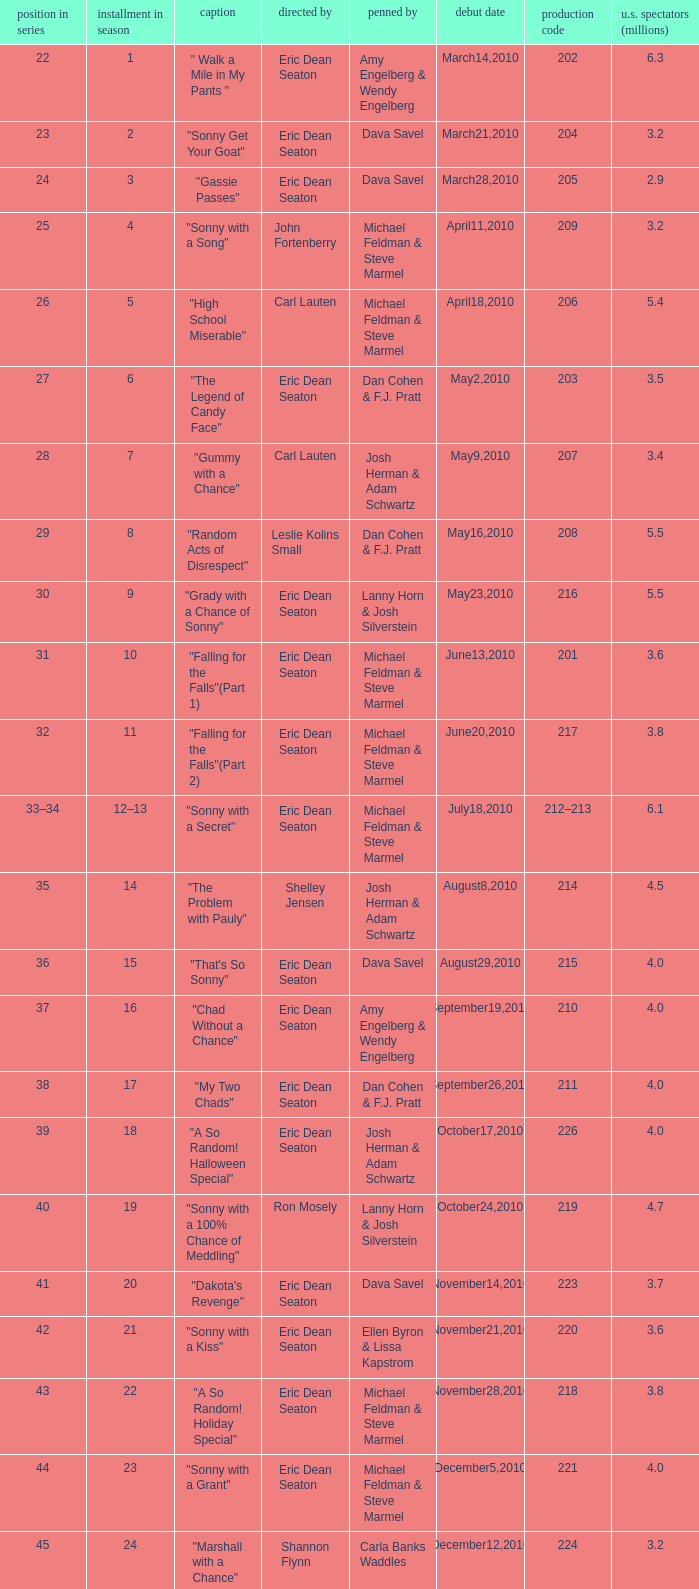Would you be able to parse every entry in this table? {'header': ['position in series', 'installment in season', 'caption', 'directed by', 'penned by', 'debut date', 'production code', 'u.s. spectators (millions)'], 'rows': [['22', '1', '" Walk a Mile in My Pants "', 'Eric Dean Seaton', 'Amy Engelberg & Wendy Engelberg', 'March14,2010', '202', '6.3'], ['23', '2', '"Sonny Get Your Goat"', 'Eric Dean Seaton', 'Dava Savel', 'March21,2010', '204', '3.2'], ['24', '3', '"Gassie Passes"', 'Eric Dean Seaton', 'Dava Savel', 'March28,2010', '205', '2.9'], ['25', '4', '"Sonny with a Song"', 'John Fortenberry', 'Michael Feldman & Steve Marmel', 'April11,2010', '209', '3.2'], ['26', '5', '"High School Miserable"', 'Carl Lauten', 'Michael Feldman & Steve Marmel', 'April18,2010', '206', '5.4'], ['27', '6', '"The Legend of Candy Face"', 'Eric Dean Seaton', 'Dan Cohen & F.J. Pratt', 'May2,2010', '203', '3.5'], ['28', '7', '"Gummy with a Chance"', 'Carl Lauten', 'Josh Herman & Adam Schwartz', 'May9,2010', '207', '3.4'], ['29', '8', '"Random Acts of Disrespect"', 'Leslie Kolins Small', 'Dan Cohen & F.J. Pratt', 'May16,2010', '208', '5.5'], ['30', '9', '"Grady with a Chance of Sonny"', 'Eric Dean Seaton', 'Lanny Horn & Josh Silverstein', 'May23,2010', '216', '5.5'], ['31', '10', '"Falling for the Falls"(Part 1)', 'Eric Dean Seaton', 'Michael Feldman & Steve Marmel', 'June13,2010', '201', '3.6'], ['32', '11', '"Falling for the Falls"(Part 2)', 'Eric Dean Seaton', 'Michael Feldman & Steve Marmel', 'June20,2010', '217', '3.8'], ['33–34', '12–13', '"Sonny with a Secret"', 'Eric Dean Seaton', 'Michael Feldman & Steve Marmel', 'July18,2010', '212–213', '6.1'], ['35', '14', '"The Problem with Pauly"', 'Shelley Jensen', 'Josh Herman & Adam Schwartz', 'August8,2010', '214', '4.5'], ['36', '15', '"That\'s So Sonny"', 'Eric Dean Seaton', 'Dava Savel', 'August29,2010', '215', '4.0'], ['37', '16', '"Chad Without a Chance"', 'Eric Dean Seaton', 'Amy Engelberg & Wendy Engelberg', 'September19,2010', '210', '4.0'], ['38', '17', '"My Two Chads"', 'Eric Dean Seaton', 'Dan Cohen & F.J. Pratt', 'September26,2010', '211', '4.0'], ['39', '18', '"A So Random! Halloween Special"', 'Eric Dean Seaton', 'Josh Herman & Adam Schwartz', 'October17,2010', '226', '4.0'], ['40', '19', '"Sonny with a 100% Chance of Meddling"', 'Ron Mosely', 'Lanny Horn & Josh Silverstein', 'October24,2010', '219', '4.7'], ['41', '20', '"Dakota\'s Revenge"', 'Eric Dean Seaton', 'Dava Savel', 'November14,2010', '223', '3.7'], ['42', '21', '"Sonny with a Kiss"', 'Eric Dean Seaton', 'Ellen Byron & Lissa Kapstrom', 'November21,2010', '220', '3.6'], ['43', '22', '"A So Random! Holiday Special"', 'Eric Dean Seaton', 'Michael Feldman & Steve Marmel', 'November28,2010', '218', '3.8'], ['44', '23', '"Sonny with a Grant"', 'Eric Dean Seaton', 'Michael Feldman & Steve Marmel', 'December5,2010', '221', '4.0'], ['45', '24', '"Marshall with a Chance"', 'Shannon Flynn', 'Carla Banks Waddles', 'December12,2010', '224', '3.2'], ['46', '25', '"Sonny with a Choice"', 'Eric Dean Seaton', 'Dan Cohen & F.J. Pratt', 'December19,2010', '222', '4.7']]} Who directed the episode that 6.3 million u.s. viewers saw? Eric Dean Seaton. 